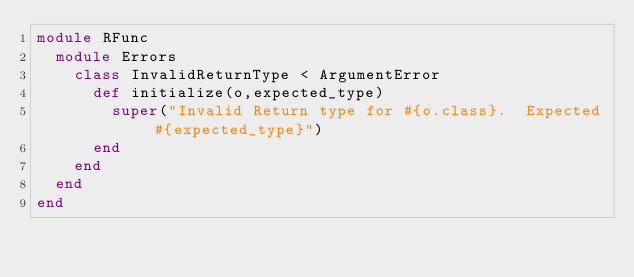<code> <loc_0><loc_0><loc_500><loc_500><_Ruby_>module RFunc
  module Errors
    class InvalidReturnType < ArgumentError
      def initialize(o,expected_type)
        super("Invalid Return type for #{o.class}.  Expected #{expected_type}")
      end
    end
  end
end</code> 